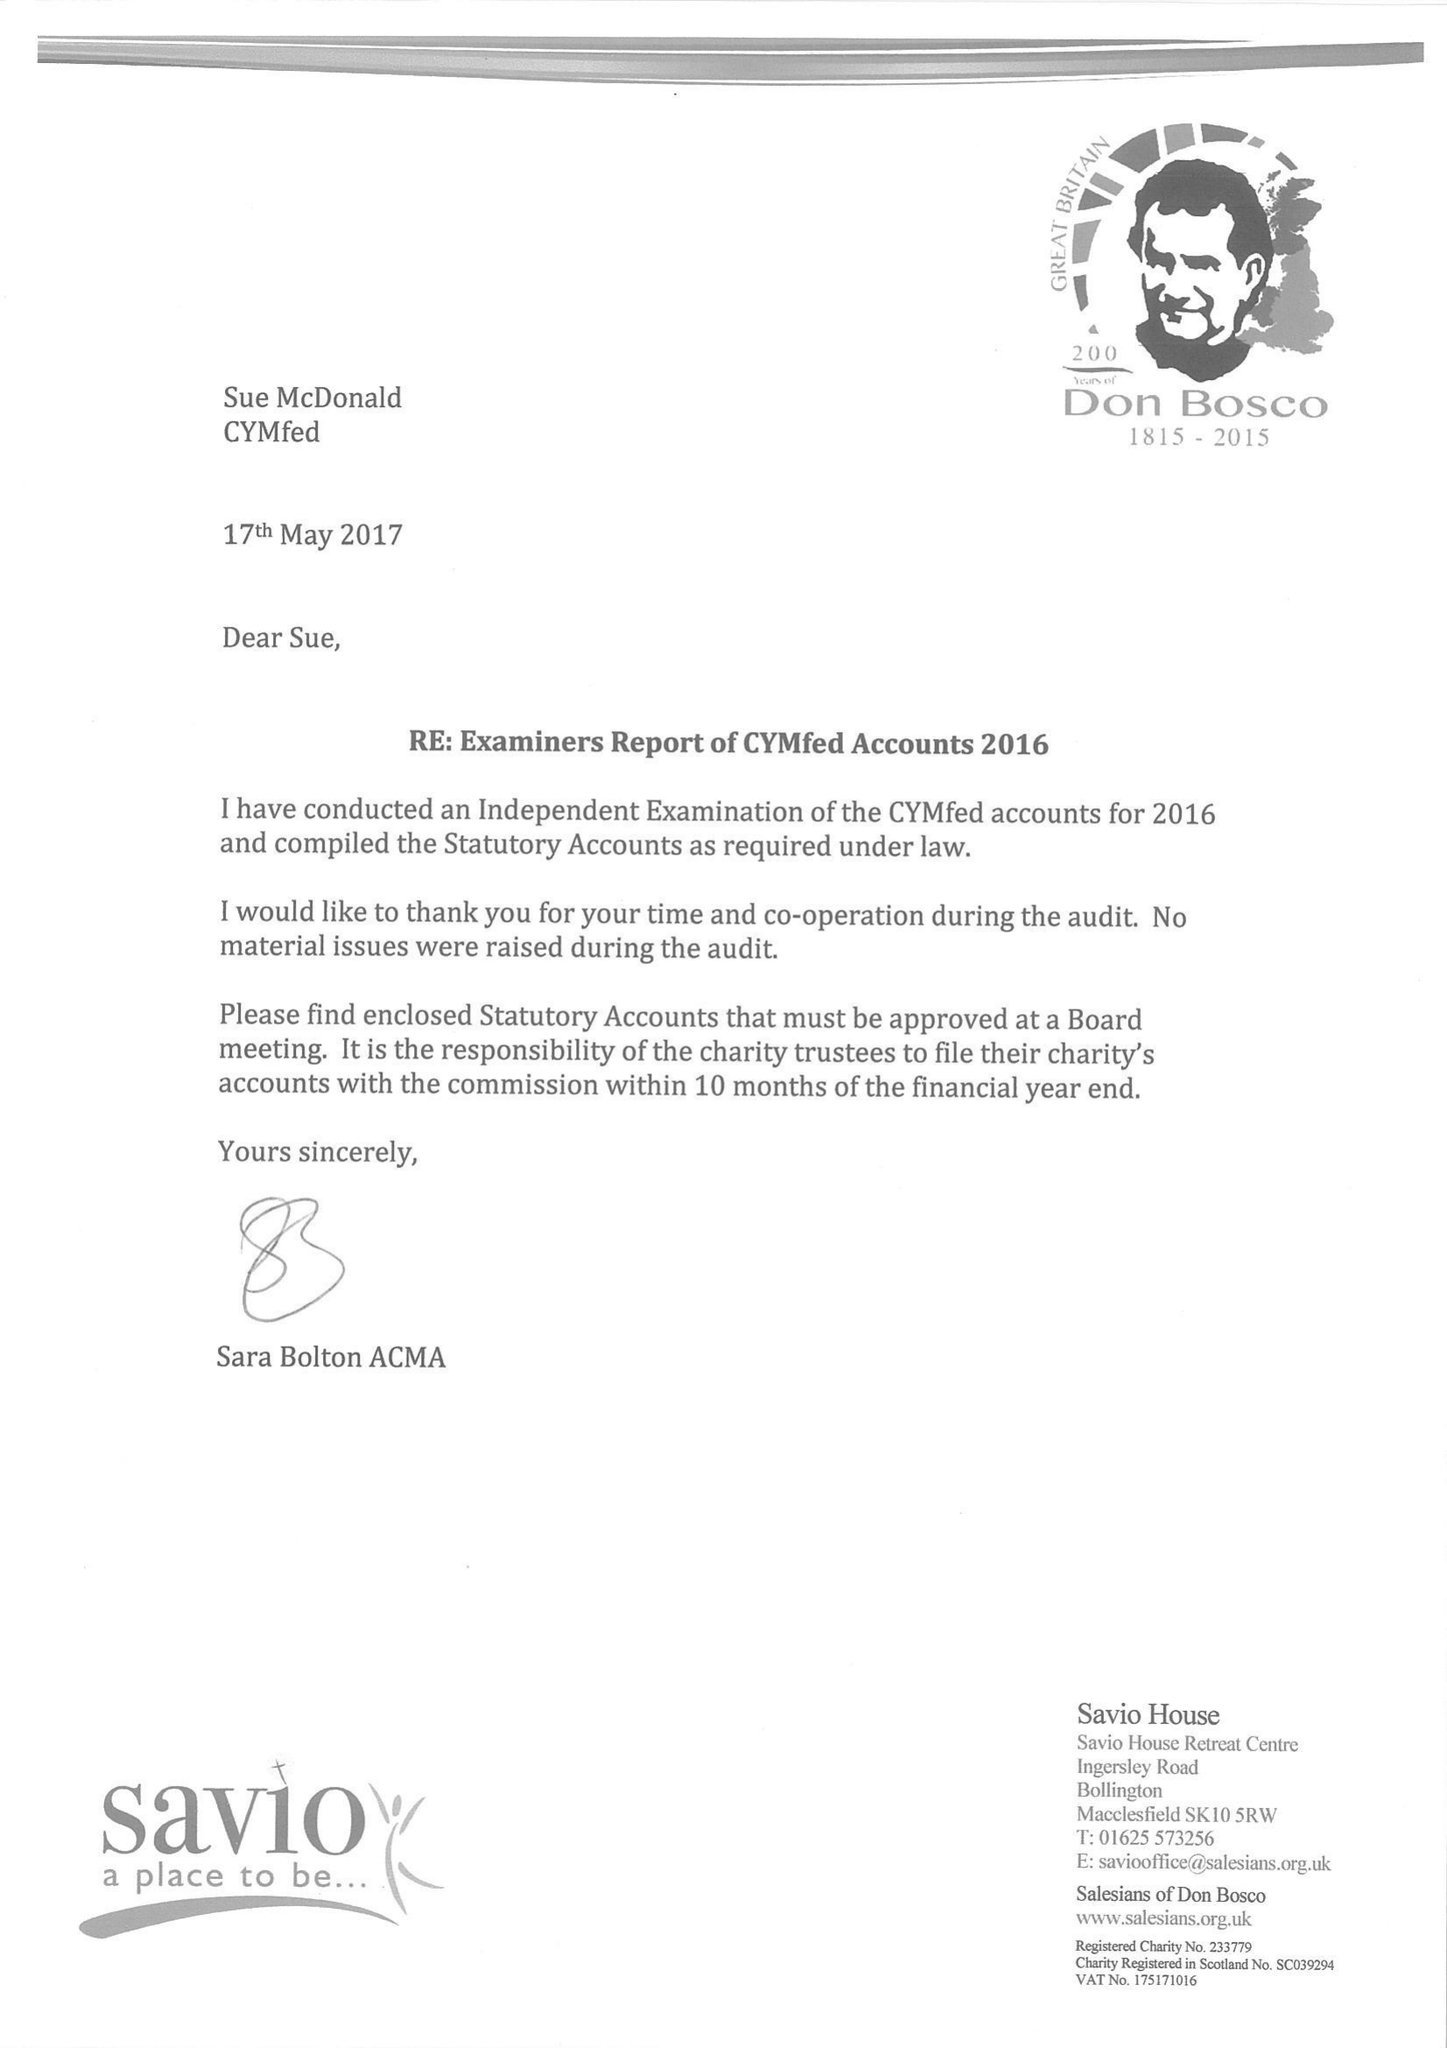What is the value for the address__street_line?
Answer the question using a single word or phrase. 39 ECCLESTON SQUARE 